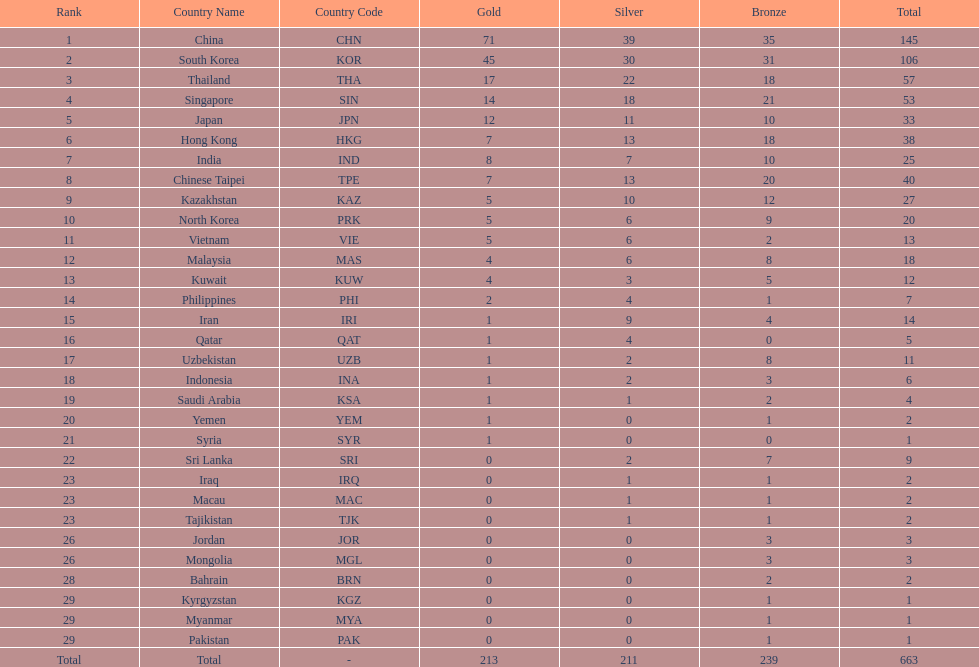What were the number of medals iran earned? 14. 